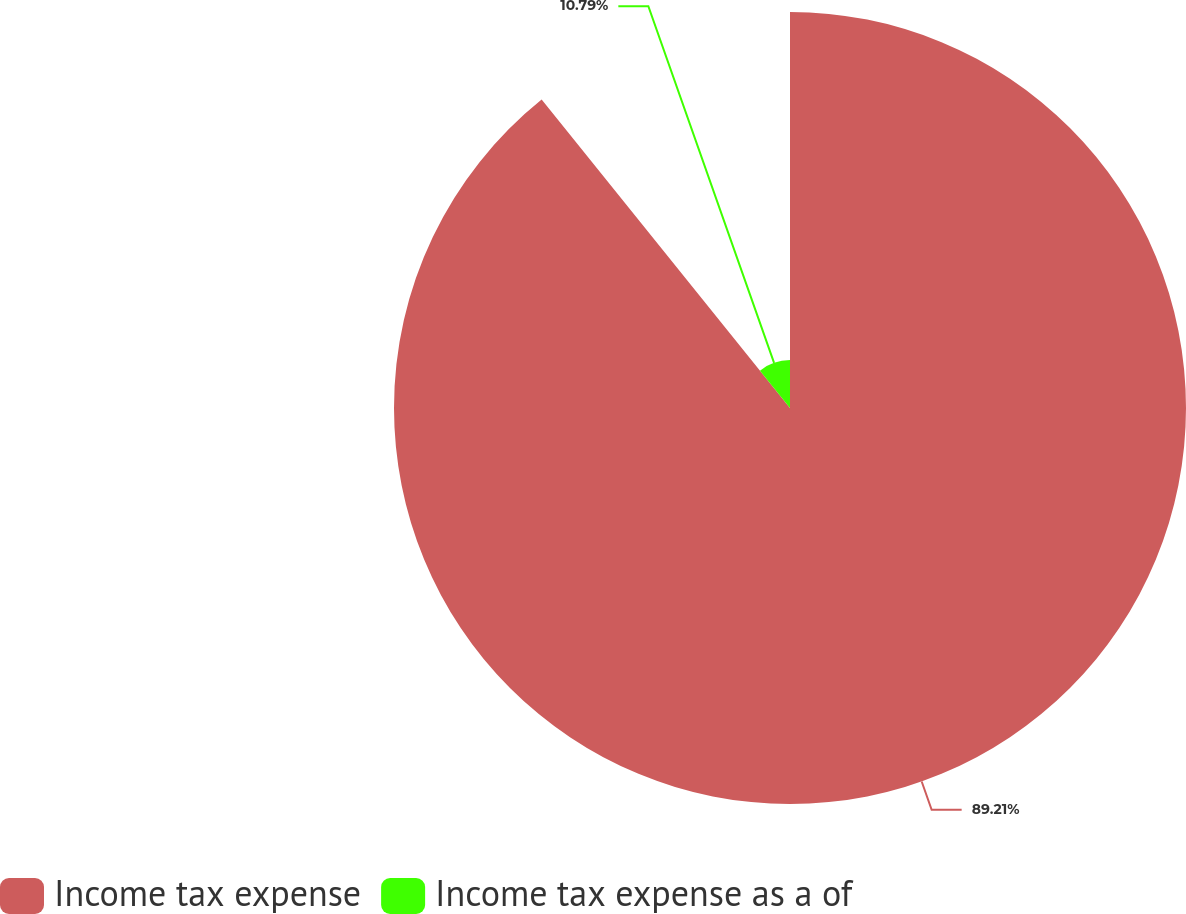Convert chart to OTSL. <chart><loc_0><loc_0><loc_500><loc_500><pie_chart><fcel>Income tax expense<fcel>Income tax expense as a of<nl><fcel>89.21%<fcel>10.79%<nl></chart> 